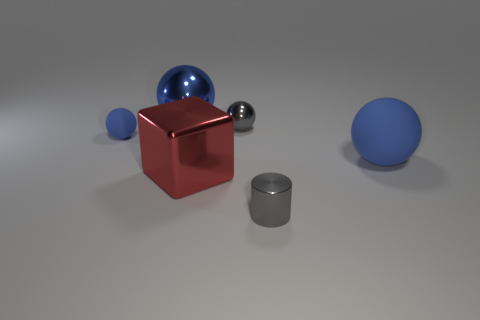What color is the big metallic thing in front of the large blue thing that is left of the large red metallic cube?
Your answer should be very brief. Red. Is the color of the big matte sphere the same as the small shiny thing on the left side of the small gray metal cylinder?
Your response must be concise. No. What size is the red cube that is made of the same material as the cylinder?
Provide a short and direct response. Large. There is a shiny thing that is the same color as the tiny rubber thing; what is its size?
Give a very brief answer. Large. Do the shiny cube and the tiny shiny cylinder have the same color?
Your answer should be compact. No. Are there any tiny gray cylinders on the left side of the tiny gray shiny thing that is behind the rubber ball on the right side of the shiny block?
Your answer should be very brief. No. What number of rubber spheres are the same size as the blue shiny ball?
Your answer should be compact. 1. There is a metallic ball that is behind the small metal ball; is it the same size as the blue rubber object that is on the left side of the tiny metal sphere?
Provide a short and direct response. No. The tiny thing that is left of the gray cylinder and to the right of the large red thing has what shape?
Your answer should be compact. Sphere. Is there a rubber ball of the same color as the small cylinder?
Your response must be concise. No. 